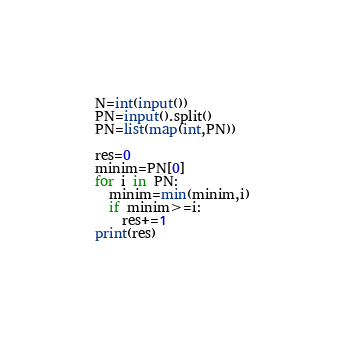<code> <loc_0><loc_0><loc_500><loc_500><_Python_>N=int(input())
PN=input().split()
PN=list(map(int,PN))

res=0
minim=PN[0]
for i in PN:
  minim=min(minim,i)
  if minim>=i:
    res+=1
print(res)
  </code> 